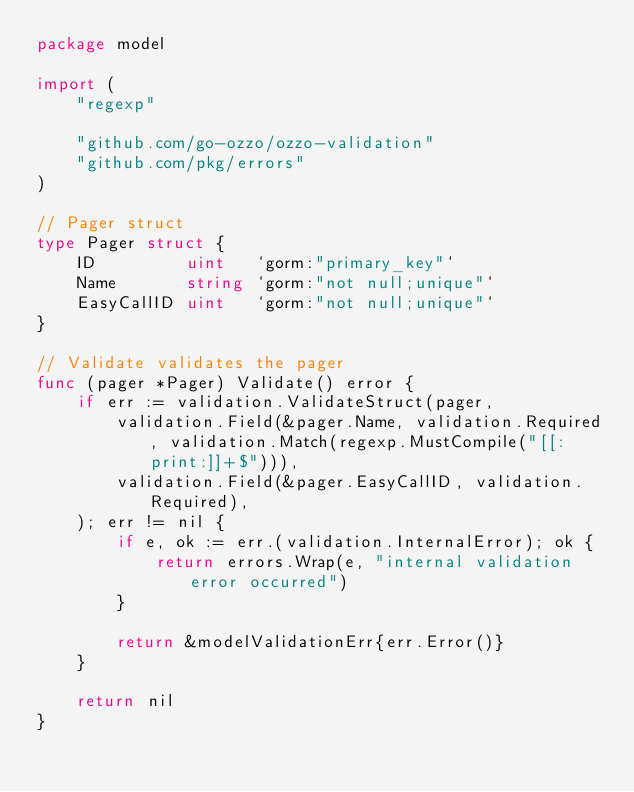Convert code to text. <code><loc_0><loc_0><loc_500><loc_500><_Go_>package model

import (
	"regexp"

	"github.com/go-ozzo/ozzo-validation"
	"github.com/pkg/errors"
)

// Pager struct
type Pager struct {
	ID         uint   `gorm:"primary_key"`
	Name       string `gorm:"not null;unique"`
	EasyCallID uint   `gorm:"not null;unique"`
}

// Validate validates the pager
func (pager *Pager) Validate() error {
	if err := validation.ValidateStruct(pager,
		validation.Field(&pager.Name, validation.Required, validation.Match(regexp.MustCompile("[[:print:]]+$"))),
		validation.Field(&pager.EasyCallID, validation.Required),
	); err != nil {
		if e, ok := err.(validation.InternalError); ok {
			return errors.Wrap(e, "internal validation error occurred")
		}

		return &modelValidationErr{err.Error()}
	}

	return nil
}
</code> 